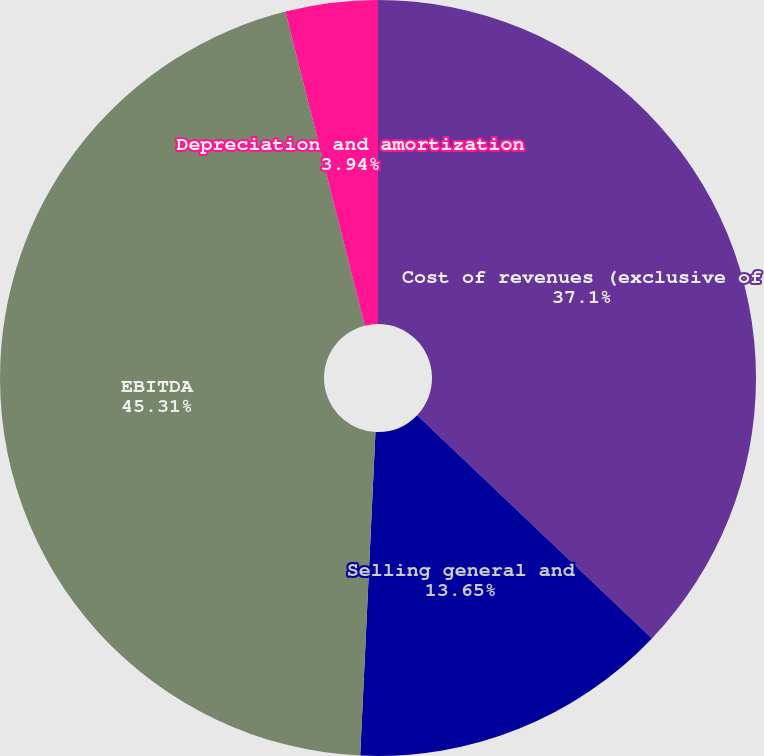Convert chart to OTSL. <chart><loc_0><loc_0><loc_500><loc_500><pie_chart><fcel>Cost of revenues (exclusive of<fcel>Selling general and<fcel>EBITDA<fcel>Depreciation and amortization<nl><fcel>37.1%<fcel>13.65%<fcel>45.31%<fcel>3.94%<nl></chart> 